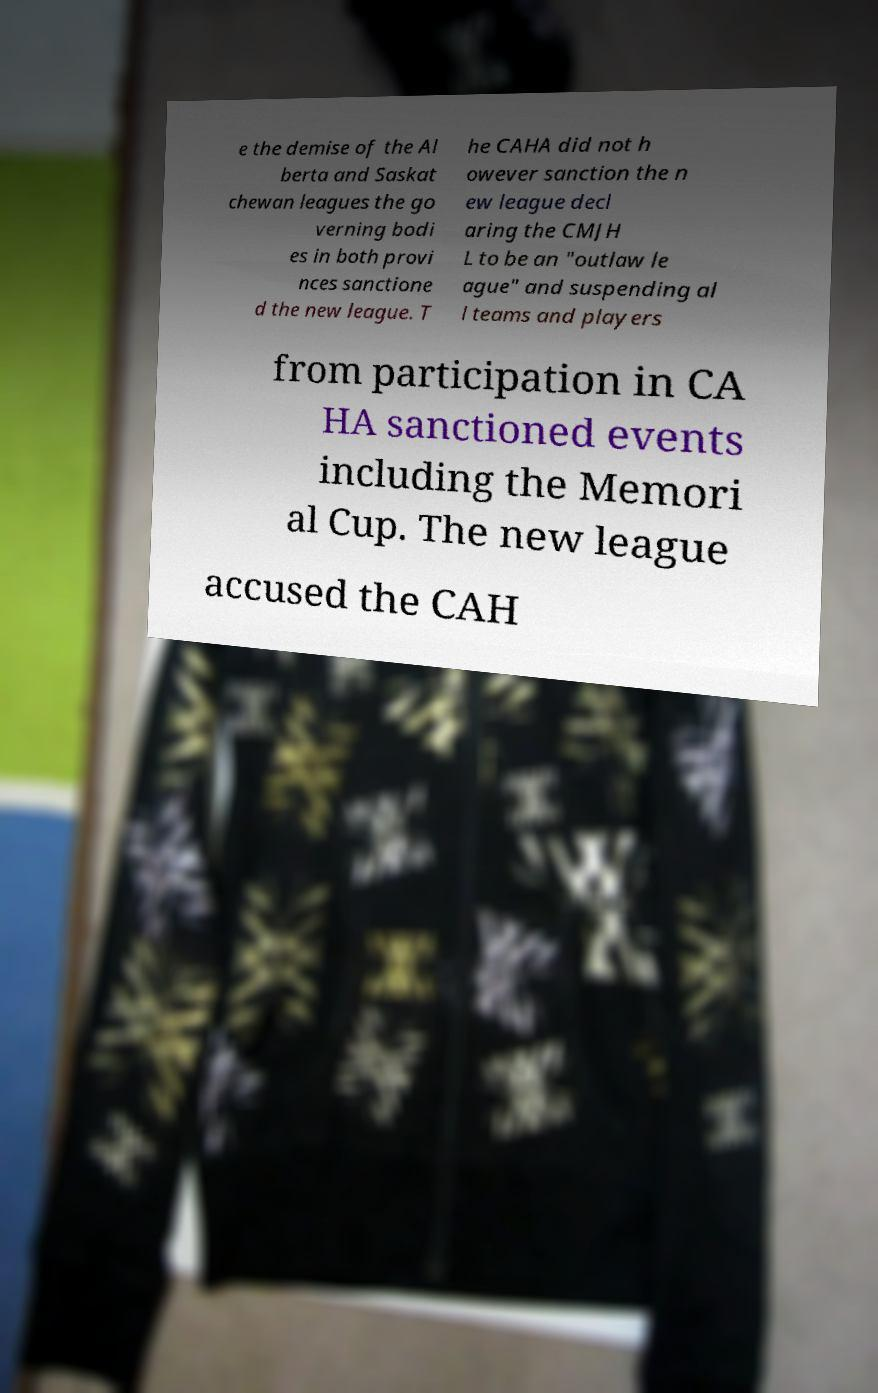Can you accurately transcribe the text from the provided image for me? e the demise of the Al berta and Saskat chewan leagues the go verning bodi es in both provi nces sanctione d the new league. T he CAHA did not h owever sanction the n ew league decl aring the CMJH L to be an "outlaw le ague" and suspending al l teams and players from participation in CA HA sanctioned events including the Memori al Cup. The new league accused the CAH 